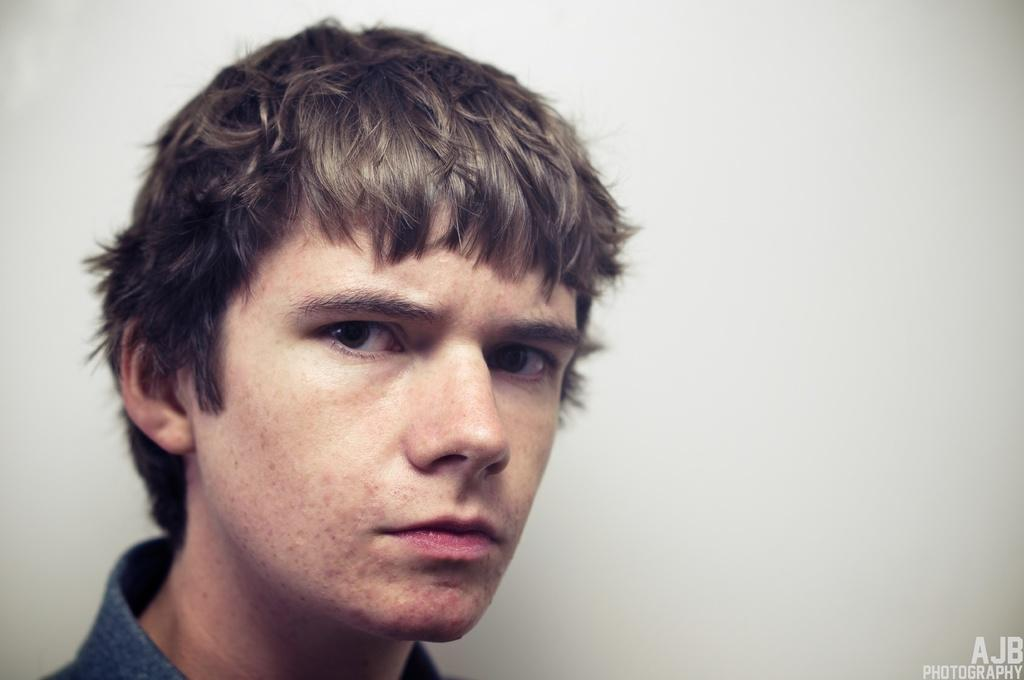What is the main subject in the foreground of the image? There is a man's face in the foreground of the image. What color is the background of the image? The background of the image is white in color. What type of iron can be seen in the man's hand in the image? There is no iron present in the image; it only features a man's face in the foreground and a white background. 